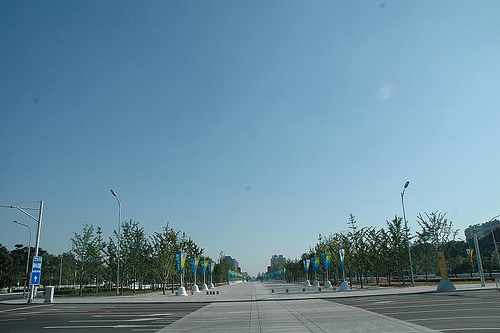<image>
Can you confirm if the sign is behind the tree? No. The sign is not behind the tree. From this viewpoint, the sign appears to be positioned elsewhere in the scene. 